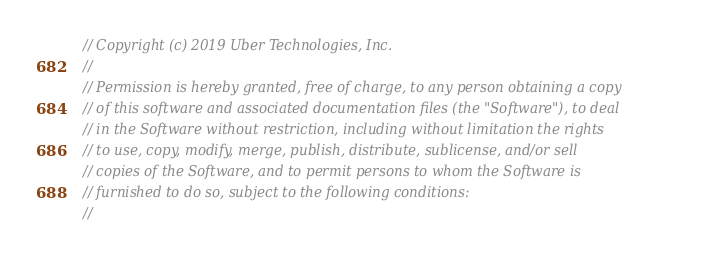Convert code to text. <code><loc_0><loc_0><loc_500><loc_500><_Go_>// Copyright (c) 2019 Uber Technologies, Inc.
//
// Permission is hereby granted, free of charge, to any person obtaining a copy
// of this software and associated documentation files (the "Software"), to deal
// in the Software without restriction, including without limitation the rights
// to use, copy, modify, merge, publish, distribute, sublicense, and/or sell
// copies of the Software, and to permit persons to whom the Software is
// furnished to do so, subject to the following conditions:
//</code> 